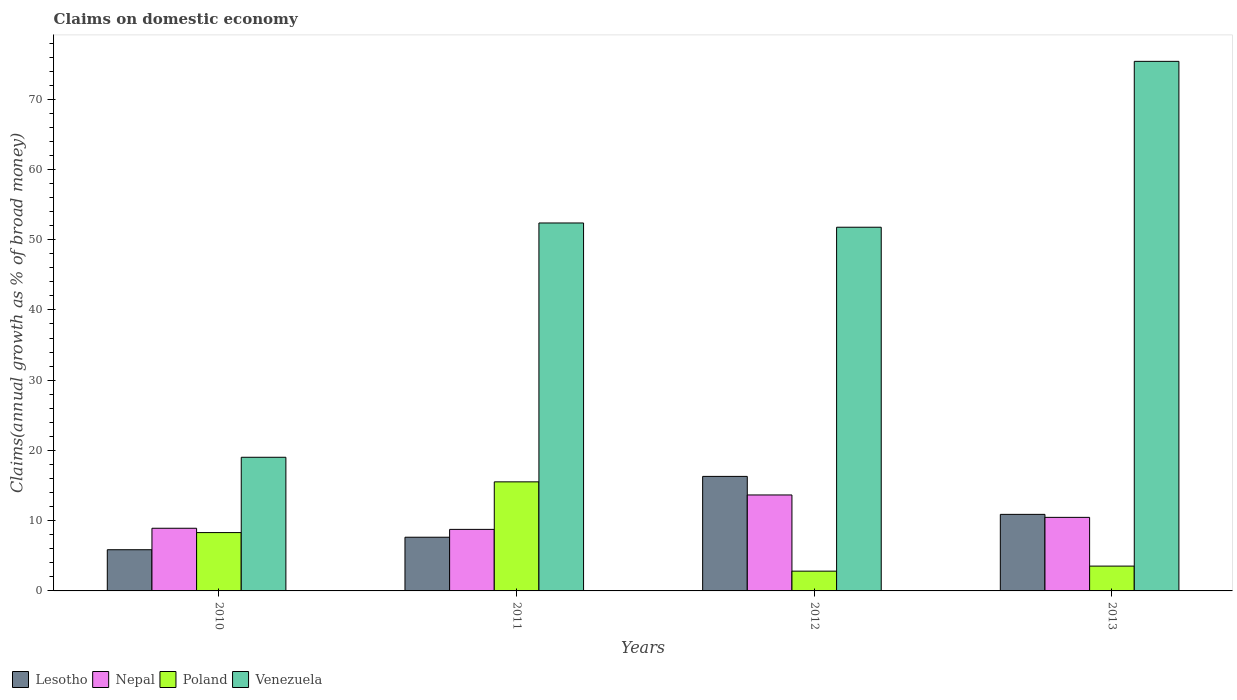How many bars are there on the 2nd tick from the left?
Your response must be concise. 4. How many bars are there on the 2nd tick from the right?
Keep it short and to the point. 4. In how many cases, is the number of bars for a given year not equal to the number of legend labels?
Offer a very short reply. 0. What is the percentage of broad money claimed on domestic economy in Poland in 2011?
Offer a terse response. 15.53. Across all years, what is the maximum percentage of broad money claimed on domestic economy in Venezuela?
Make the answer very short. 75.39. Across all years, what is the minimum percentage of broad money claimed on domestic economy in Lesotho?
Offer a very short reply. 5.86. What is the total percentage of broad money claimed on domestic economy in Venezuela in the graph?
Make the answer very short. 198.57. What is the difference between the percentage of broad money claimed on domestic economy in Venezuela in 2010 and that in 2011?
Your answer should be very brief. -33.35. What is the difference between the percentage of broad money claimed on domestic economy in Lesotho in 2012 and the percentage of broad money claimed on domestic economy in Venezuela in 2013?
Your answer should be compact. -59.08. What is the average percentage of broad money claimed on domestic economy in Poland per year?
Your answer should be compact. 7.54. In the year 2011, what is the difference between the percentage of broad money claimed on domestic economy in Lesotho and percentage of broad money claimed on domestic economy in Nepal?
Your response must be concise. -1.12. What is the ratio of the percentage of broad money claimed on domestic economy in Venezuela in 2011 to that in 2012?
Provide a short and direct response. 1.01. What is the difference between the highest and the second highest percentage of broad money claimed on domestic economy in Nepal?
Make the answer very short. 3.19. What is the difference between the highest and the lowest percentage of broad money claimed on domestic economy in Venezuela?
Your response must be concise. 56.36. Is the sum of the percentage of broad money claimed on domestic economy in Poland in 2010 and 2012 greater than the maximum percentage of broad money claimed on domestic economy in Nepal across all years?
Your answer should be very brief. No. Is it the case that in every year, the sum of the percentage of broad money claimed on domestic economy in Venezuela and percentage of broad money claimed on domestic economy in Poland is greater than the sum of percentage of broad money claimed on domestic economy in Nepal and percentage of broad money claimed on domestic economy in Lesotho?
Your answer should be very brief. Yes. What does the 2nd bar from the left in 2012 represents?
Your answer should be compact. Nepal. What does the 3rd bar from the right in 2010 represents?
Your answer should be very brief. Nepal. How many years are there in the graph?
Provide a short and direct response. 4. Are the values on the major ticks of Y-axis written in scientific E-notation?
Keep it short and to the point. No. What is the title of the graph?
Provide a short and direct response. Claims on domestic economy. What is the label or title of the Y-axis?
Keep it short and to the point. Claims(annual growth as % of broad money). What is the Claims(annual growth as % of broad money) in Lesotho in 2010?
Ensure brevity in your answer.  5.86. What is the Claims(annual growth as % of broad money) in Nepal in 2010?
Ensure brevity in your answer.  8.92. What is the Claims(annual growth as % of broad money) of Poland in 2010?
Make the answer very short. 8.31. What is the Claims(annual growth as % of broad money) in Venezuela in 2010?
Your answer should be compact. 19.03. What is the Claims(annual growth as % of broad money) of Lesotho in 2011?
Your answer should be compact. 7.64. What is the Claims(annual growth as % of broad money) in Nepal in 2011?
Provide a succinct answer. 8.76. What is the Claims(annual growth as % of broad money) in Poland in 2011?
Provide a short and direct response. 15.53. What is the Claims(annual growth as % of broad money) in Venezuela in 2011?
Offer a very short reply. 52.38. What is the Claims(annual growth as % of broad money) in Lesotho in 2012?
Keep it short and to the point. 16.3. What is the Claims(annual growth as % of broad money) of Nepal in 2012?
Your response must be concise. 13.66. What is the Claims(annual growth as % of broad money) in Poland in 2012?
Keep it short and to the point. 2.81. What is the Claims(annual growth as % of broad money) in Venezuela in 2012?
Offer a very short reply. 51.77. What is the Claims(annual growth as % of broad money) of Lesotho in 2013?
Give a very brief answer. 10.9. What is the Claims(annual growth as % of broad money) in Nepal in 2013?
Provide a short and direct response. 10.47. What is the Claims(annual growth as % of broad money) in Poland in 2013?
Make the answer very short. 3.53. What is the Claims(annual growth as % of broad money) in Venezuela in 2013?
Offer a very short reply. 75.39. Across all years, what is the maximum Claims(annual growth as % of broad money) of Lesotho?
Ensure brevity in your answer.  16.3. Across all years, what is the maximum Claims(annual growth as % of broad money) of Nepal?
Your answer should be very brief. 13.66. Across all years, what is the maximum Claims(annual growth as % of broad money) in Poland?
Give a very brief answer. 15.53. Across all years, what is the maximum Claims(annual growth as % of broad money) in Venezuela?
Provide a short and direct response. 75.39. Across all years, what is the minimum Claims(annual growth as % of broad money) of Lesotho?
Offer a very short reply. 5.86. Across all years, what is the minimum Claims(annual growth as % of broad money) of Nepal?
Keep it short and to the point. 8.76. Across all years, what is the minimum Claims(annual growth as % of broad money) in Poland?
Your answer should be compact. 2.81. Across all years, what is the minimum Claims(annual growth as % of broad money) of Venezuela?
Your answer should be compact. 19.03. What is the total Claims(annual growth as % of broad money) in Lesotho in the graph?
Provide a short and direct response. 40.71. What is the total Claims(annual growth as % of broad money) in Nepal in the graph?
Provide a short and direct response. 41.81. What is the total Claims(annual growth as % of broad money) of Poland in the graph?
Offer a terse response. 30.18. What is the total Claims(annual growth as % of broad money) of Venezuela in the graph?
Your response must be concise. 198.57. What is the difference between the Claims(annual growth as % of broad money) in Lesotho in 2010 and that in 2011?
Your response must be concise. -1.78. What is the difference between the Claims(annual growth as % of broad money) of Nepal in 2010 and that in 2011?
Your response must be concise. 0.16. What is the difference between the Claims(annual growth as % of broad money) of Poland in 2010 and that in 2011?
Give a very brief answer. -7.22. What is the difference between the Claims(annual growth as % of broad money) of Venezuela in 2010 and that in 2011?
Your answer should be very brief. -33.35. What is the difference between the Claims(annual growth as % of broad money) of Lesotho in 2010 and that in 2012?
Offer a very short reply. -10.44. What is the difference between the Claims(annual growth as % of broad money) of Nepal in 2010 and that in 2012?
Provide a short and direct response. -4.74. What is the difference between the Claims(annual growth as % of broad money) of Poland in 2010 and that in 2012?
Give a very brief answer. 5.49. What is the difference between the Claims(annual growth as % of broad money) of Venezuela in 2010 and that in 2012?
Provide a succinct answer. -32.75. What is the difference between the Claims(annual growth as % of broad money) in Lesotho in 2010 and that in 2013?
Keep it short and to the point. -5.03. What is the difference between the Claims(annual growth as % of broad money) of Nepal in 2010 and that in 2013?
Provide a succinct answer. -1.55. What is the difference between the Claims(annual growth as % of broad money) in Poland in 2010 and that in 2013?
Ensure brevity in your answer.  4.77. What is the difference between the Claims(annual growth as % of broad money) of Venezuela in 2010 and that in 2013?
Provide a short and direct response. -56.36. What is the difference between the Claims(annual growth as % of broad money) of Lesotho in 2011 and that in 2012?
Give a very brief answer. -8.66. What is the difference between the Claims(annual growth as % of broad money) of Nepal in 2011 and that in 2012?
Your answer should be compact. -4.9. What is the difference between the Claims(annual growth as % of broad money) in Poland in 2011 and that in 2012?
Give a very brief answer. 12.71. What is the difference between the Claims(annual growth as % of broad money) in Venezuela in 2011 and that in 2012?
Your answer should be very brief. 0.6. What is the difference between the Claims(annual growth as % of broad money) of Lesotho in 2011 and that in 2013?
Keep it short and to the point. -3.25. What is the difference between the Claims(annual growth as % of broad money) of Nepal in 2011 and that in 2013?
Provide a short and direct response. -1.71. What is the difference between the Claims(annual growth as % of broad money) of Poland in 2011 and that in 2013?
Provide a succinct answer. 11.99. What is the difference between the Claims(annual growth as % of broad money) of Venezuela in 2011 and that in 2013?
Offer a very short reply. -23.01. What is the difference between the Claims(annual growth as % of broad money) of Lesotho in 2012 and that in 2013?
Your answer should be very brief. 5.41. What is the difference between the Claims(annual growth as % of broad money) of Nepal in 2012 and that in 2013?
Ensure brevity in your answer.  3.19. What is the difference between the Claims(annual growth as % of broad money) in Poland in 2012 and that in 2013?
Make the answer very short. -0.72. What is the difference between the Claims(annual growth as % of broad money) in Venezuela in 2012 and that in 2013?
Your answer should be very brief. -23.61. What is the difference between the Claims(annual growth as % of broad money) of Lesotho in 2010 and the Claims(annual growth as % of broad money) of Nepal in 2011?
Your answer should be compact. -2.9. What is the difference between the Claims(annual growth as % of broad money) in Lesotho in 2010 and the Claims(annual growth as % of broad money) in Poland in 2011?
Offer a very short reply. -9.66. What is the difference between the Claims(annual growth as % of broad money) of Lesotho in 2010 and the Claims(annual growth as % of broad money) of Venezuela in 2011?
Keep it short and to the point. -46.52. What is the difference between the Claims(annual growth as % of broad money) of Nepal in 2010 and the Claims(annual growth as % of broad money) of Poland in 2011?
Offer a very short reply. -6.61. What is the difference between the Claims(annual growth as % of broad money) of Nepal in 2010 and the Claims(annual growth as % of broad money) of Venezuela in 2011?
Your answer should be compact. -43.46. What is the difference between the Claims(annual growth as % of broad money) in Poland in 2010 and the Claims(annual growth as % of broad money) in Venezuela in 2011?
Offer a very short reply. -44.07. What is the difference between the Claims(annual growth as % of broad money) of Lesotho in 2010 and the Claims(annual growth as % of broad money) of Nepal in 2012?
Your answer should be compact. -7.8. What is the difference between the Claims(annual growth as % of broad money) of Lesotho in 2010 and the Claims(annual growth as % of broad money) of Poland in 2012?
Keep it short and to the point. 3.05. What is the difference between the Claims(annual growth as % of broad money) of Lesotho in 2010 and the Claims(annual growth as % of broad money) of Venezuela in 2012?
Provide a short and direct response. -45.91. What is the difference between the Claims(annual growth as % of broad money) in Nepal in 2010 and the Claims(annual growth as % of broad money) in Poland in 2012?
Give a very brief answer. 6.11. What is the difference between the Claims(annual growth as % of broad money) in Nepal in 2010 and the Claims(annual growth as % of broad money) in Venezuela in 2012?
Keep it short and to the point. -42.85. What is the difference between the Claims(annual growth as % of broad money) of Poland in 2010 and the Claims(annual growth as % of broad money) of Venezuela in 2012?
Offer a very short reply. -43.47. What is the difference between the Claims(annual growth as % of broad money) of Lesotho in 2010 and the Claims(annual growth as % of broad money) of Nepal in 2013?
Keep it short and to the point. -4.61. What is the difference between the Claims(annual growth as % of broad money) in Lesotho in 2010 and the Claims(annual growth as % of broad money) in Poland in 2013?
Your answer should be compact. 2.33. What is the difference between the Claims(annual growth as % of broad money) of Lesotho in 2010 and the Claims(annual growth as % of broad money) of Venezuela in 2013?
Offer a very short reply. -69.52. What is the difference between the Claims(annual growth as % of broad money) in Nepal in 2010 and the Claims(annual growth as % of broad money) in Poland in 2013?
Make the answer very short. 5.39. What is the difference between the Claims(annual growth as % of broad money) in Nepal in 2010 and the Claims(annual growth as % of broad money) in Venezuela in 2013?
Offer a terse response. -66.47. What is the difference between the Claims(annual growth as % of broad money) in Poland in 2010 and the Claims(annual growth as % of broad money) in Venezuela in 2013?
Your response must be concise. -67.08. What is the difference between the Claims(annual growth as % of broad money) of Lesotho in 2011 and the Claims(annual growth as % of broad money) of Nepal in 2012?
Make the answer very short. -6.02. What is the difference between the Claims(annual growth as % of broad money) of Lesotho in 2011 and the Claims(annual growth as % of broad money) of Poland in 2012?
Your answer should be very brief. 4.83. What is the difference between the Claims(annual growth as % of broad money) in Lesotho in 2011 and the Claims(annual growth as % of broad money) in Venezuela in 2012?
Offer a very short reply. -44.13. What is the difference between the Claims(annual growth as % of broad money) in Nepal in 2011 and the Claims(annual growth as % of broad money) in Poland in 2012?
Ensure brevity in your answer.  5.95. What is the difference between the Claims(annual growth as % of broad money) in Nepal in 2011 and the Claims(annual growth as % of broad money) in Venezuela in 2012?
Offer a terse response. -43.01. What is the difference between the Claims(annual growth as % of broad money) in Poland in 2011 and the Claims(annual growth as % of broad money) in Venezuela in 2012?
Give a very brief answer. -36.25. What is the difference between the Claims(annual growth as % of broad money) in Lesotho in 2011 and the Claims(annual growth as % of broad money) in Nepal in 2013?
Offer a very short reply. -2.83. What is the difference between the Claims(annual growth as % of broad money) of Lesotho in 2011 and the Claims(annual growth as % of broad money) of Poland in 2013?
Make the answer very short. 4.11. What is the difference between the Claims(annual growth as % of broad money) of Lesotho in 2011 and the Claims(annual growth as % of broad money) of Venezuela in 2013?
Make the answer very short. -67.74. What is the difference between the Claims(annual growth as % of broad money) in Nepal in 2011 and the Claims(annual growth as % of broad money) in Poland in 2013?
Keep it short and to the point. 5.23. What is the difference between the Claims(annual growth as % of broad money) of Nepal in 2011 and the Claims(annual growth as % of broad money) of Venezuela in 2013?
Provide a succinct answer. -66.63. What is the difference between the Claims(annual growth as % of broad money) of Poland in 2011 and the Claims(annual growth as % of broad money) of Venezuela in 2013?
Provide a short and direct response. -59.86. What is the difference between the Claims(annual growth as % of broad money) in Lesotho in 2012 and the Claims(annual growth as % of broad money) in Nepal in 2013?
Your response must be concise. 5.83. What is the difference between the Claims(annual growth as % of broad money) in Lesotho in 2012 and the Claims(annual growth as % of broad money) in Poland in 2013?
Provide a succinct answer. 12.77. What is the difference between the Claims(annual growth as % of broad money) of Lesotho in 2012 and the Claims(annual growth as % of broad money) of Venezuela in 2013?
Your response must be concise. -59.08. What is the difference between the Claims(annual growth as % of broad money) of Nepal in 2012 and the Claims(annual growth as % of broad money) of Poland in 2013?
Your response must be concise. 10.13. What is the difference between the Claims(annual growth as % of broad money) of Nepal in 2012 and the Claims(annual growth as % of broad money) of Venezuela in 2013?
Provide a short and direct response. -61.73. What is the difference between the Claims(annual growth as % of broad money) in Poland in 2012 and the Claims(annual growth as % of broad money) in Venezuela in 2013?
Provide a succinct answer. -72.57. What is the average Claims(annual growth as % of broad money) of Lesotho per year?
Provide a succinct answer. 10.18. What is the average Claims(annual growth as % of broad money) in Nepal per year?
Provide a succinct answer. 10.45. What is the average Claims(annual growth as % of broad money) in Poland per year?
Keep it short and to the point. 7.54. What is the average Claims(annual growth as % of broad money) of Venezuela per year?
Provide a succinct answer. 49.64. In the year 2010, what is the difference between the Claims(annual growth as % of broad money) in Lesotho and Claims(annual growth as % of broad money) in Nepal?
Ensure brevity in your answer.  -3.06. In the year 2010, what is the difference between the Claims(annual growth as % of broad money) of Lesotho and Claims(annual growth as % of broad money) of Poland?
Provide a succinct answer. -2.44. In the year 2010, what is the difference between the Claims(annual growth as % of broad money) in Lesotho and Claims(annual growth as % of broad money) in Venezuela?
Provide a short and direct response. -13.16. In the year 2010, what is the difference between the Claims(annual growth as % of broad money) in Nepal and Claims(annual growth as % of broad money) in Poland?
Offer a terse response. 0.61. In the year 2010, what is the difference between the Claims(annual growth as % of broad money) in Nepal and Claims(annual growth as % of broad money) in Venezuela?
Keep it short and to the point. -10.11. In the year 2010, what is the difference between the Claims(annual growth as % of broad money) in Poland and Claims(annual growth as % of broad money) in Venezuela?
Your answer should be very brief. -10.72. In the year 2011, what is the difference between the Claims(annual growth as % of broad money) of Lesotho and Claims(annual growth as % of broad money) of Nepal?
Your answer should be compact. -1.12. In the year 2011, what is the difference between the Claims(annual growth as % of broad money) in Lesotho and Claims(annual growth as % of broad money) in Poland?
Your response must be concise. -7.88. In the year 2011, what is the difference between the Claims(annual growth as % of broad money) of Lesotho and Claims(annual growth as % of broad money) of Venezuela?
Provide a short and direct response. -44.74. In the year 2011, what is the difference between the Claims(annual growth as % of broad money) of Nepal and Claims(annual growth as % of broad money) of Poland?
Ensure brevity in your answer.  -6.77. In the year 2011, what is the difference between the Claims(annual growth as % of broad money) of Nepal and Claims(annual growth as % of broad money) of Venezuela?
Offer a very short reply. -43.62. In the year 2011, what is the difference between the Claims(annual growth as % of broad money) of Poland and Claims(annual growth as % of broad money) of Venezuela?
Keep it short and to the point. -36.85. In the year 2012, what is the difference between the Claims(annual growth as % of broad money) of Lesotho and Claims(annual growth as % of broad money) of Nepal?
Ensure brevity in your answer.  2.64. In the year 2012, what is the difference between the Claims(annual growth as % of broad money) of Lesotho and Claims(annual growth as % of broad money) of Poland?
Your answer should be compact. 13.49. In the year 2012, what is the difference between the Claims(annual growth as % of broad money) of Lesotho and Claims(annual growth as % of broad money) of Venezuela?
Offer a very short reply. -35.47. In the year 2012, what is the difference between the Claims(annual growth as % of broad money) in Nepal and Claims(annual growth as % of broad money) in Poland?
Provide a short and direct response. 10.85. In the year 2012, what is the difference between the Claims(annual growth as % of broad money) in Nepal and Claims(annual growth as % of broad money) in Venezuela?
Provide a succinct answer. -38.11. In the year 2012, what is the difference between the Claims(annual growth as % of broad money) of Poland and Claims(annual growth as % of broad money) of Venezuela?
Your response must be concise. -48.96. In the year 2013, what is the difference between the Claims(annual growth as % of broad money) in Lesotho and Claims(annual growth as % of broad money) in Nepal?
Offer a terse response. 0.43. In the year 2013, what is the difference between the Claims(annual growth as % of broad money) in Lesotho and Claims(annual growth as % of broad money) in Poland?
Make the answer very short. 7.36. In the year 2013, what is the difference between the Claims(annual growth as % of broad money) in Lesotho and Claims(annual growth as % of broad money) in Venezuela?
Your response must be concise. -64.49. In the year 2013, what is the difference between the Claims(annual growth as % of broad money) in Nepal and Claims(annual growth as % of broad money) in Poland?
Your answer should be compact. 6.94. In the year 2013, what is the difference between the Claims(annual growth as % of broad money) in Nepal and Claims(annual growth as % of broad money) in Venezuela?
Ensure brevity in your answer.  -64.92. In the year 2013, what is the difference between the Claims(annual growth as % of broad money) of Poland and Claims(annual growth as % of broad money) of Venezuela?
Ensure brevity in your answer.  -71.86. What is the ratio of the Claims(annual growth as % of broad money) of Lesotho in 2010 to that in 2011?
Your response must be concise. 0.77. What is the ratio of the Claims(annual growth as % of broad money) of Nepal in 2010 to that in 2011?
Make the answer very short. 1.02. What is the ratio of the Claims(annual growth as % of broad money) of Poland in 2010 to that in 2011?
Ensure brevity in your answer.  0.53. What is the ratio of the Claims(annual growth as % of broad money) of Venezuela in 2010 to that in 2011?
Keep it short and to the point. 0.36. What is the ratio of the Claims(annual growth as % of broad money) in Lesotho in 2010 to that in 2012?
Your answer should be compact. 0.36. What is the ratio of the Claims(annual growth as % of broad money) in Nepal in 2010 to that in 2012?
Offer a terse response. 0.65. What is the ratio of the Claims(annual growth as % of broad money) of Poland in 2010 to that in 2012?
Your answer should be very brief. 2.95. What is the ratio of the Claims(annual growth as % of broad money) in Venezuela in 2010 to that in 2012?
Your answer should be very brief. 0.37. What is the ratio of the Claims(annual growth as % of broad money) of Lesotho in 2010 to that in 2013?
Ensure brevity in your answer.  0.54. What is the ratio of the Claims(annual growth as % of broad money) of Nepal in 2010 to that in 2013?
Provide a succinct answer. 0.85. What is the ratio of the Claims(annual growth as % of broad money) of Poland in 2010 to that in 2013?
Give a very brief answer. 2.35. What is the ratio of the Claims(annual growth as % of broad money) in Venezuela in 2010 to that in 2013?
Give a very brief answer. 0.25. What is the ratio of the Claims(annual growth as % of broad money) in Lesotho in 2011 to that in 2012?
Make the answer very short. 0.47. What is the ratio of the Claims(annual growth as % of broad money) in Nepal in 2011 to that in 2012?
Offer a very short reply. 0.64. What is the ratio of the Claims(annual growth as % of broad money) of Poland in 2011 to that in 2012?
Provide a succinct answer. 5.52. What is the ratio of the Claims(annual growth as % of broad money) of Venezuela in 2011 to that in 2012?
Give a very brief answer. 1.01. What is the ratio of the Claims(annual growth as % of broad money) of Lesotho in 2011 to that in 2013?
Provide a short and direct response. 0.7. What is the ratio of the Claims(annual growth as % of broad money) of Nepal in 2011 to that in 2013?
Provide a short and direct response. 0.84. What is the ratio of the Claims(annual growth as % of broad money) in Poland in 2011 to that in 2013?
Ensure brevity in your answer.  4.39. What is the ratio of the Claims(annual growth as % of broad money) in Venezuela in 2011 to that in 2013?
Ensure brevity in your answer.  0.69. What is the ratio of the Claims(annual growth as % of broad money) in Lesotho in 2012 to that in 2013?
Your answer should be very brief. 1.5. What is the ratio of the Claims(annual growth as % of broad money) in Nepal in 2012 to that in 2013?
Offer a terse response. 1.3. What is the ratio of the Claims(annual growth as % of broad money) in Poland in 2012 to that in 2013?
Offer a terse response. 0.8. What is the ratio of the Claims(annual growth as % of broad money) in Venezuela in 2012 to that in 2013?
Provide a succinct answer. 0.69. What is the difference between the highest and the second highest Claims(annual growth as % of broad money) of Lesotho?
Keep it short and to the point. 5.41. What is the difference between the highest and the second highest Claims(annual growth as % of broad money) in Nepal?
Keep it short and to the point. 3.19. What is the difference between the highest and the second highest Claims(annual growth as % of broad money) in Poland?
Provide a succinct answer. 7.22. What is the difference between the highest and the second highest Claims(annual growth as % of broad money) of Venezuela?
Your answer should be compact. 23.01. What is the difference between the highest and the lowest Claims(annual growth as % of broad money) of Lesotho?
Provide a succinct answer. 10.44. What is the difference between the highest and the lowest Claims(annual growth as % of broad money) of Nepal?
Your response must be concise. 4.9. What is the difference between the highest and the lowest Claims(annual growth as % of broad money) in Poland?
Offer a very short reply. 12.71. What is the difference between the highest and the lowest Claims(annual growth as % of broad money) of Venezuela?
Offer a terse response. 56.36. 